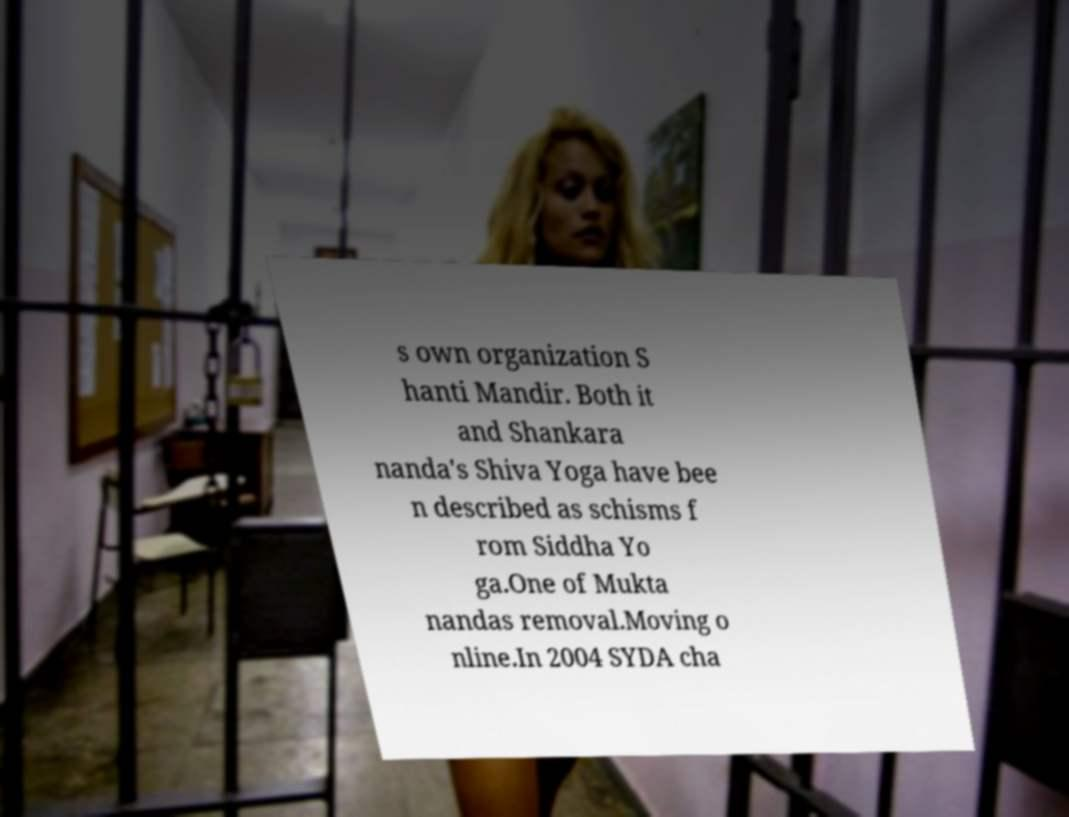Could you assist in decoding the text presented in this image and type it out clearly? s own organization S hanti Mandir. Both it and Shankara nanda's Shiva Yoga have bee n described as schisms f rom Siddha Yo ga.One of Mukta nandas removal.Moving o nline.In 2004 SYDA cha 